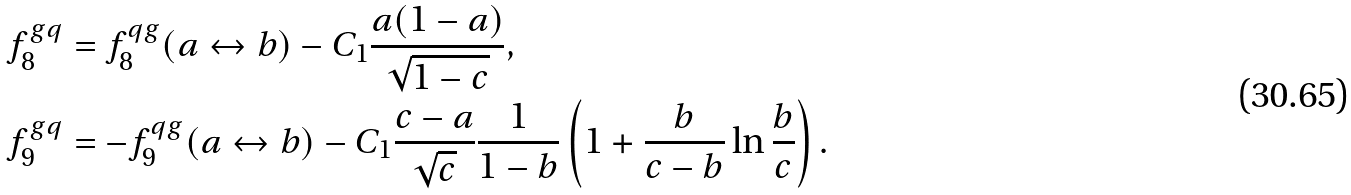Convert formula to latex. <formula><loc_0><loc_0><loc_500><loc_500>f ^ { g q } _ { 8 } & = f ^ { q g } _ { 8 } ( a \leftrightarrow b ) - C _ { 1 } \frac { a ( 1 - a ) } { \sqrt { 1 - c } } , \\ f ^ { g q } _ { 9 } & = - f ^ { q g } _ { 9 } ( a \leftrightarrow b ) - C _ { 1 } \frac { c - a } { \sqrt { c } } \frac { 1 } { 1 - b } \left ( 1 + \frac { b } { c - b } \ln { \frac { b } { c } } \right ) .</formula> 